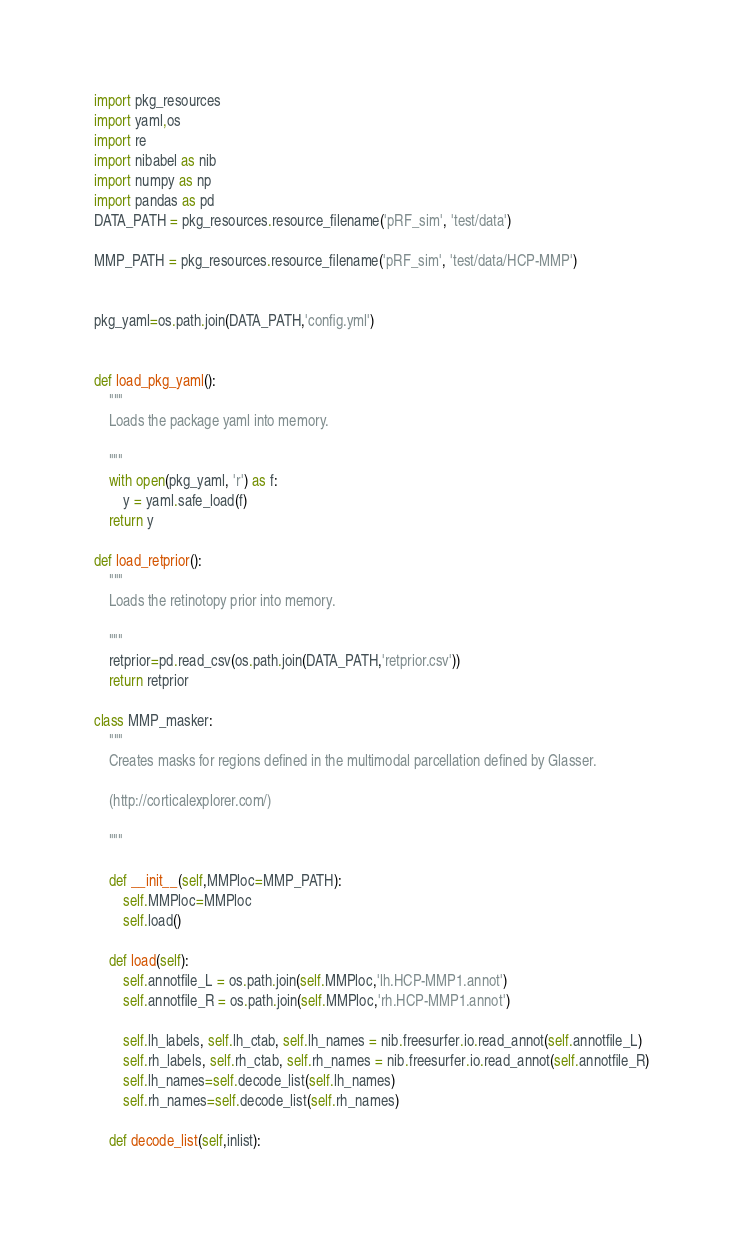<code> <loc_0><loc_0><loc_500><loc_500><_Python_>import pkg_resources
import yaml,os
import re
import nibabel as nib
import numpy as np
import pandas as pd
DATA_PATH = pkg_resources.resource_filename('pRF_sim', 'test/data')

MMP_PATH = pkg_resources.resource_filename('pRF_sim', 'test/data/HCP-MMP')


pkg_yaml=os.path.join(DATA_PATH,'config.yml')


def load_pkg_yaml():
    """
    Loads the package yaml into memory.
    
    """
    with open(pkg_yaml, 'r') as f:
        y = yaml.safe_load(f)
    return y

def load_retprior():
    """
    Loads the retinotopy prior into memory.
    
    """
    retprior=pd.read_csv(os.path.join(DATA_PATH,'retprior.csv'))
    return retprior

class MMP_masker:
    """
    Creates masks for regions defined in the multimodal parcellation defined by Glasser. 
    
    (http://corticalexplorer.com/)
    
    """
    
    def __init__(self,MMPloc=MMP_PATH):
        self.MMPloc=MMPloc
        self.load()

    def load(self):
        self.annotfile_L = os.path.join(self.MMPloc,'lh.HCP-MMP1.annot')
        self.annotfile_R = os.path.join(self.MMPloc,'rh.HCP-MMP1.annot')

        self.lh_labels, self.lh_ctab, self.lh_names = nib.freesurfer.io.read_annot(self.annotfile_L)
        self.rh_labels, self.rh_ctab, self.rh_names = nib.freesurfer.io.read_annot(self.annotfile_R)
        self.lh_names=self.decode_list(self.lh_names)
        self.rh_names=self.decode_list(self.rh_names)

    def decode_list(self,inlist):</code> 